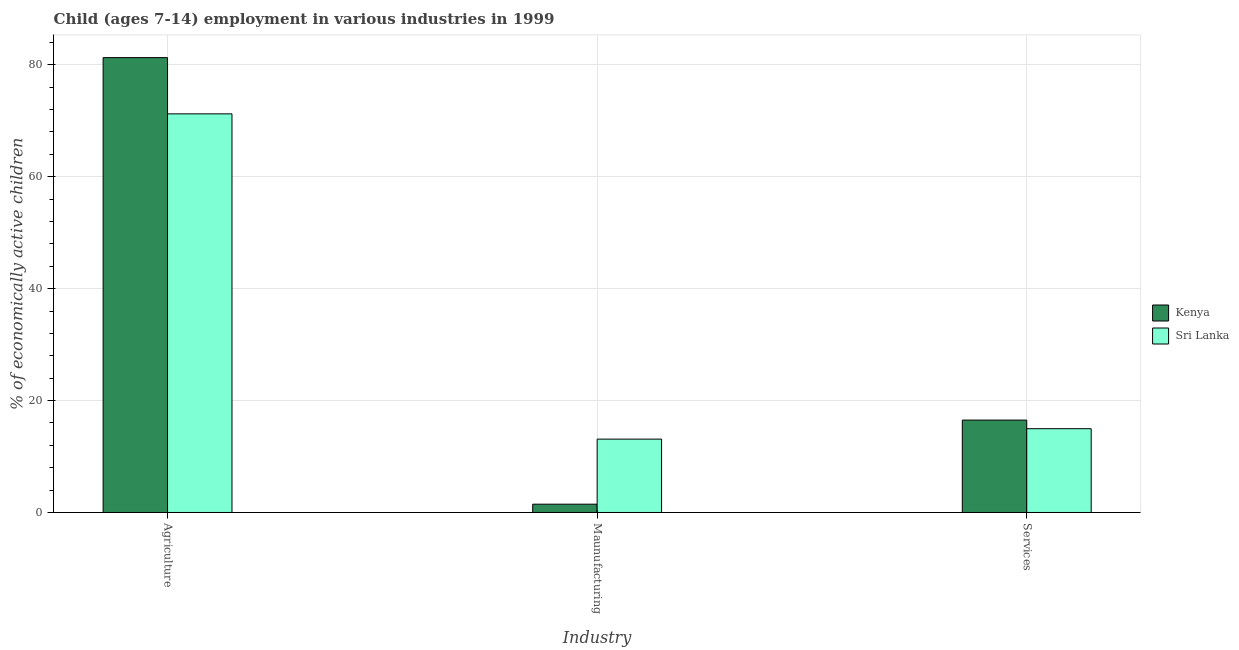How many different coloured bars are there?
Your answer should be very brief. 2. Are the number of bars per tick equal to the number of legend labels?
Keep it short and to the point. Yes. Are the number of bars on each tick of the X-axis equal?
Provide a short and direct response. Yes. How many bars are there on the 1st tick from the right?
Your answer should be compact. 2. What is the label of the 2nd group of bars from the left?
Offer a very short reply. Maunufacturing. What is the percentage of economically active children in agriculture in Kenya?
Provide a short and direct response. 81.28. Across all countries, what is the maximum percentage of economically active children in agriculture?
Provide a succinct answer. 81.28. Across all countries, what is the minimum percentage of economically active children in manufacturing?
Make the answer very short. 1.48. In which country was the percentage of economically active children in agriculture maximum?
Offer a terse response. Kenya. In which country was the percentage of economically active children in agriculture minimum?
Your answer should be very brief. Sri Lanka. What is the total percentage of economically active children in agriculture in the graph?
Your answer should be very brief. 152.51. What is the difference between the percentage of economically active children in services in Kenya and that in Sri Lanka?
Provide a short and direct response. 1.54. What is the difference between the percentage of economically active children in agriculture in Kenya and the percentage of economically active children in manufacturing in Sri Lanka?
Your answer should be very brief. 68.17. What is the average percentage of economically active children in manufacturing per country?
Ensure brevity in your answer.  7.3. What is the difference between the percentage of economically active children in services and percentage of economically active children in agriculture in Kenya?
Keep it short and to the point. -64.77. In how many countries, is the percentage of economically active children in services greater than 32 %?
Offer a terse response. 0. What is the ratio of the percentage of economically active children in manufacturing in Sri Lanka to that in Kenya?
Provide a short and direct response. 8.85. Is the difference between the percentage of economically active children in services in Kenya and Sri Lanka greater than the difference between the percentage of economically active children in manufacturing in Kenya and Sri Lanka?
Provide a succinct answer. Yes. What is the difference between the highest and the second highest percentage of economically active children in manufacturing?
Your response must be concise. 11.63. What is the difference between the highest and the lowest percentage of economically active children in agriculture?
Your answer should be very brief. 10.05. Is the sum of the percentage of economically active children in services in Sri Lanka and Kenya greater than the maximum percentage of economically active children in agriculture across all countries?
Offer a terse response. No. What does the 2nd bar from the left in Maunufacturing represents?
Your response must be concise. Sri Lanka. What does the 1st bar from the right in Services represents?
Ensure brevity in your answer.  Sri Lanka. Is it the case that in every country, the sum of the percentage of economically active children in agriculture and percentage of economically active children in manufacturing is greater than the percentage of economically active children in services?
Your response must be concise. Yes. Are all the bars in the graph horizontal?
Provide a succinct answer. No. How many countries are there in the graph?
Provide a short and direct response. 2. What is the difference between two consecutive major ticks on the Y-axis?
Make the answer very short. 20. Does the graph contain any zero values?
Offer a terse response. No. Does the graph contain grids?
Give a very brief answer. Yes. How many legend labels are there?
Provide a short and direct response. 2. What is the title of the graph?
Provide a succinct answer. Child (ages 7-14) employment in various industries in 1999. What is the label or title of the X-axis?
Keep it short and to the point. Industry. What is the label or title of the Y-axis?
Provide a short and direct response. % of economically active children. What is the % of economically active children of Kenya in Agriculture?
Provide a succinct answer. 81.28. What is the % of economically active children of Sri Lanka in Agriculture?
Offer a very short reply. 71.23. What is the % of economically active children of Kenya in Maunufacturing?
Your answer should be compact. 1.48. What is the % of economically active children of Sri Lanka in Maunufacturing?
Keep it short and to the point. 13.11. What is the % of economically active children in Kenya in Services?
Keep it short and to the point. 16.51. What is the % of economically active children in Sri Lanka in Services?
Offer a terse response. 14.97. Across all Industry, what is the maximum % of economically active children of Kenya?
Give a very brief answer. 81.28. Across all Industry, what is the maximum % of economically active children in Sri Lanka?
Your response must be concise. 71.23. Across all Industry, what is the minimum % of economically active children of Kenya?
Give a very brief answer. 1.48. Across all Industry, what is the minimum % of economically active children of Sri Lanka?
Your response must be concise. 13.11. What is the total % of economically active children of Kenya in the graph?
Give a very brief answer. 99.27. What is the total % of economically active children in Sri Lanka in the graph?
Your response must be concise. 99.31. What is the difference between the % of economically active children in Kenya in Agriculture and that in Maunufacturing?
Provide a succinct answer. 79.8. What is the difference between the % of economically active children of Sri Lanka in Agriculture and that in Maunufacturing?
Keep it short and to the point. 58.12. What is the difference between the % of economically active children of Kenya in Agriculture and that in Services?
Ensure brevity in your answer.  64.77. What is the difference between the % of economically active children of Sri Lanka in Agriculture and that in Services?
Provide a succinct answer. 56.26. What is the difference between the % of economically active children of Kenya in Maunufacturing and that in Services?
Offer a terse response. -15.03. What is the difference between the % of economically active children of Sri Lanka in Maunufacturing and that in Services?
Keep it short and to the point. -1.86. What is the difference between the % of economically active children in Kenya in Agriculture and the % of economically active children in Sri Lanka in Maunufacturing?
Your answer should be compact. 68.17. What is the difference between the % of economically active children of Kenya in Agriculture and the % of economically active children of Sri Lanka in Services?
Provide a succinct answer. 66.31. What is the difference between the % of economically active children in Kenya in Maunufacturing and the % of economically active children in Sri Lanka in Services?
Provide a short and direct response. -13.49. What is the average % of economically active children of Kenya per Industry?
Your response must be concise. 33.09. What is the average % of economically active children in Sri Lanka per Industry?
Offer a terse response. 33.1. What is the difference between the % of economically active children of Kenya and % of economically active children of Sri Lanka in Agriculture?
Offer a terse response. 10.05. What is the difference between the % of economically active children of Kenya and % of economically active children of Sri Lanka in Maunufacturing?
Give a very brief answer. -11.63. What is the difference between the % of economically active children of Kenya and % of economically active children of Sri Lanka in Services?
Provide a succinct answer. 1.54. What is the ratio of the % of economically active children in Kenya in Agriculture to that in Maunufacturing?
Provide a succinct answer. 54.84. What is the ratio of the % of economically active children in Sri Lanka in Agriculture to that in Maunufacturing?
Your answer should be very brief. 5.43. What is the ratio of the % of economically active children in Kenya in Agriculture to that in Services?
Offer a very short reply. 4.92. What is the ratio of the % of economically active children of Sri Lanka in Agriculture to that in Services?
Offer a terse response. 4.76. What is the ratio of the % of economically active children of Kenya in Maunufacturing to that in Services?
Make the answer very short. 0.09. What is the ratio of the % of economically active children of Sri Lanka in Maunufacturing to that in Services?
Keep it short and to the point. 0.88. What is the difference between the highest and the second highest % of economically active children of Kenya?
Give a very brief answer. 64.77. What is the difference between the highest and the second highest % of economically active children of Sri Lanka?
Your response must be concise. 56.26. What is the difference between the highest and the lowest % of economically active children of Kenya?
Provide a short and direct response. 79.8. What is the difference between the highest and the lowest % of economically active children of Sri Lanka?
Make the answer very short. 58.12. 